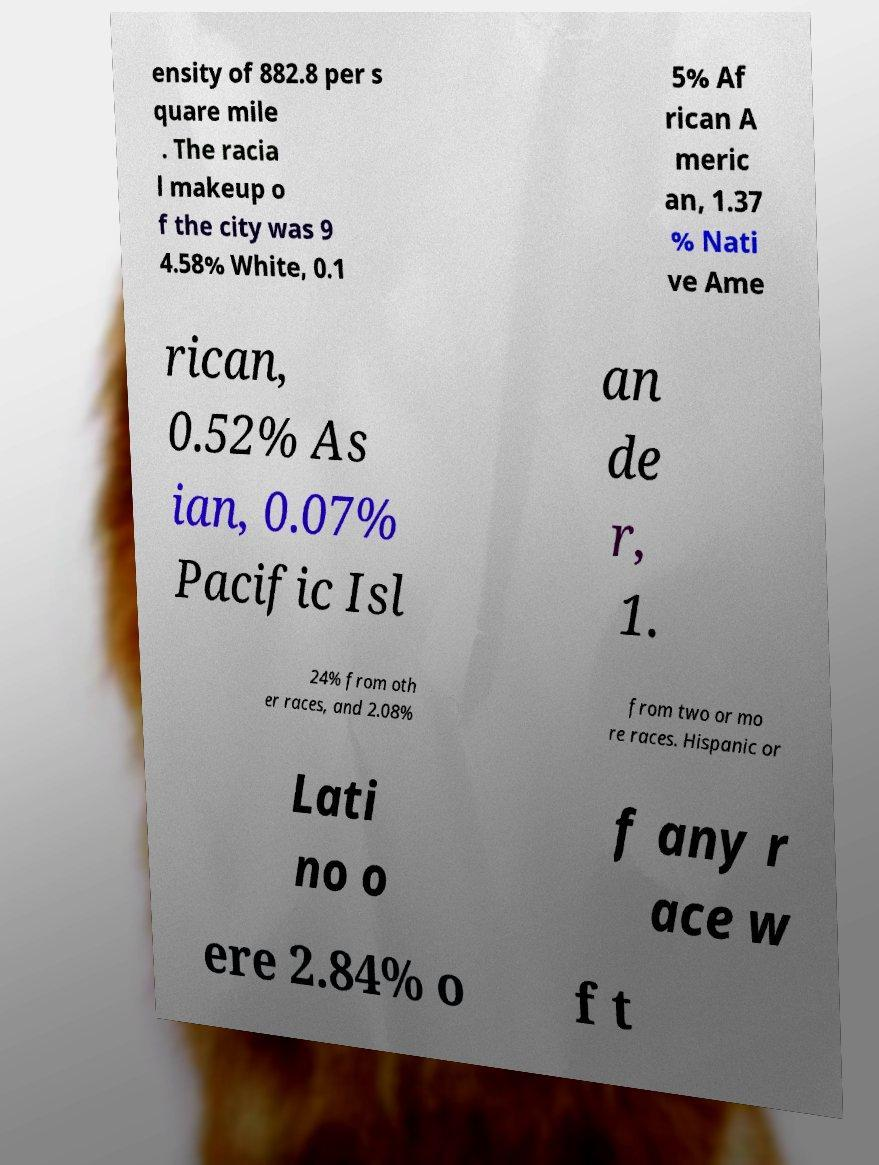Can you read and provide the text displayed in the image?This photo seems to have some interesting text. Can you extract and type it out for me? ensity of 882.8 per s quare mile . The racia l makeup o f the city was 9 4.58% White, 0.1 5% Af rican A meric an, 1.37 % Nati ve Ame rican, 0.52% As ian, 0.07% Pacific Isl an de r, 1. 24% from oth er races, and 2.08% from two or mo re races. Hispanic or Lati no o f any r ace w ere 2.84% o f t 